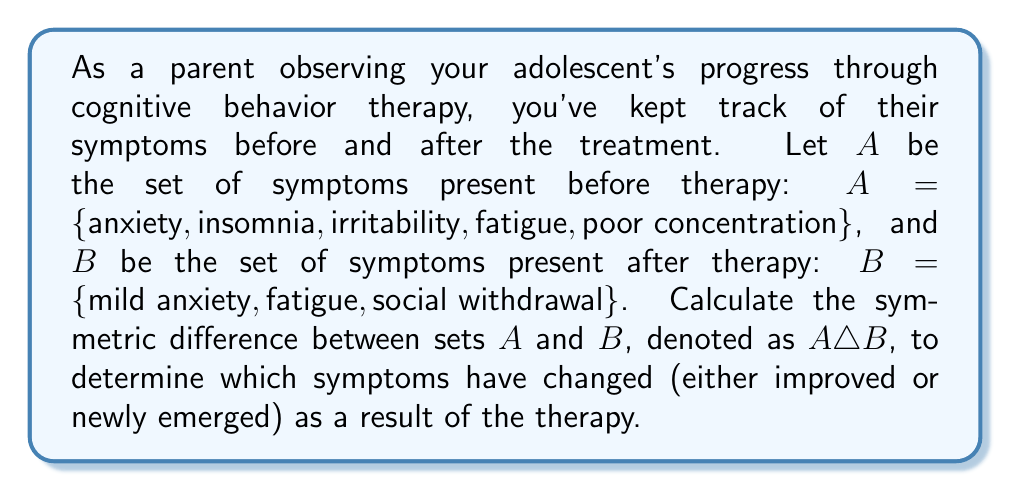Show me your answer to this math problem. To solve this problem, we need to understand the concept of symmetric difference and then apply it to the given sets.

1. The symmetric difference of two sets $A$ and $B$, denoted as $A \triangle B$, is defined as the set of elements that are in either $A$ or $B$, but not in both. It can be expressed as:

   $A \triangle B = (A \setminus B) \cup (B \setminus A)$

   where $\setminus$ represents set difference.

2. Let's first identify the elements in each set:
   $A = \{anxiety, insomnia, irritability, fatigue, poor concentration\}$
   $B = \{mild anxiety, fatigue, social withdrawal\}$

3. Now, let's find $A \setminus B$ (elements in $A$ but not in $B$):
   $A \setminus B = \{anxiety, insomnia, irritability, poor concentration\}$
   Note: We consider "anxiety" and "mild anxiety" as different symptoms.

4. Next, let's find $B \setminus A$ (elements in $B$ but not in $A$):
   $B \setminus A = \{mild anxiety, social withdrawal\}$

5. Finally, we take the union of these two sets to get $A \triangle B$:
   $A \triangle B = \{anxiety, insomnia, irritability, poor concentration, mild anxiety, social withdrawal\}$

This symmetric difference represents the symptoms that have either improved (those in $A$ but not in $B$) or newly emerged (those in $B$ but not in $A$) after the therapy.
Answer: $A \triangle B = \{anxiety, insomnia, irritability, poor concentration, mild anxiety, social withdrawal\}$ 